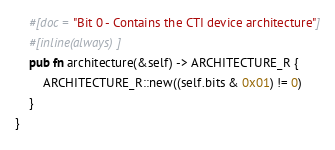<code> <loc_0><loc_0><loc_500><loc_500><_Rust_>    #[doc = "Bit 0 - Contains the CTI device architecture"]
    #[inline(always)]
    pub fn architecture(&self) -> ARCHITECTURE_R {
        ARCHITECTURE_R::new((self.bits & 0x01) != 0)
    }
}
</code> 